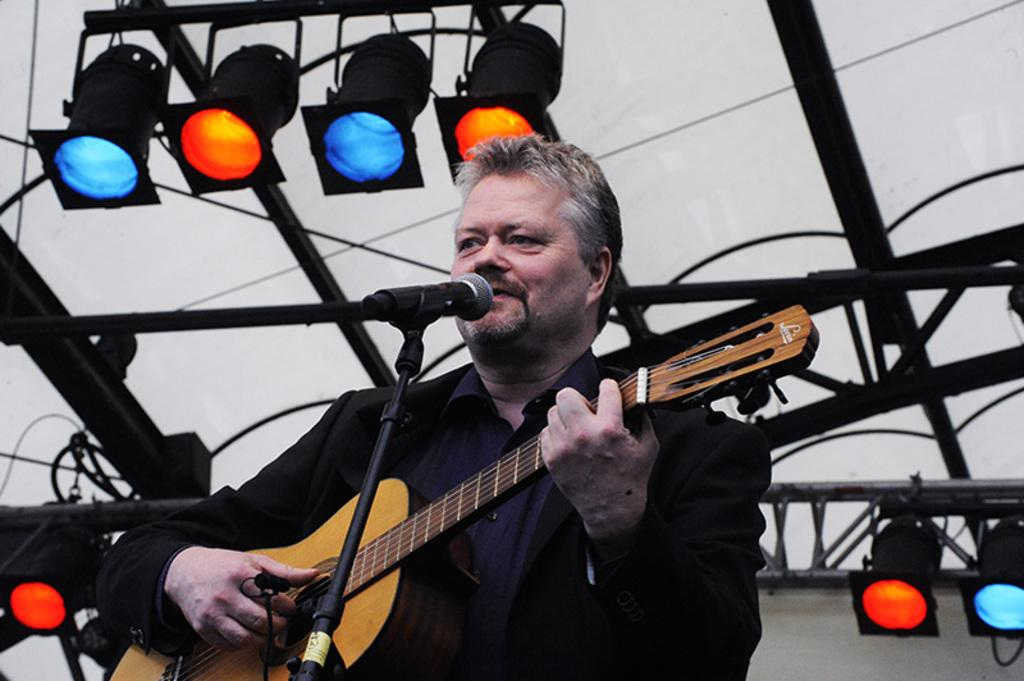What is the man holding in the image? The man is holding a guitar in the image. What is the man doing with the guitar? The man is playing the guitar in the image. What other activity is the man engaged in? The man is singing in the image. What is in front of the man to help amplify his voice? There is a microphone in front of the man in the image. What is the microphone attached to? There is a microphone stand in front of the man in the image. What colors of lights can be seen in the background? There are blue and red lights in the background of the image. What type of grain is being used to support the microphone stand in the image? There is no grain present in the image, and the microphone stand is not supported by any grain. 